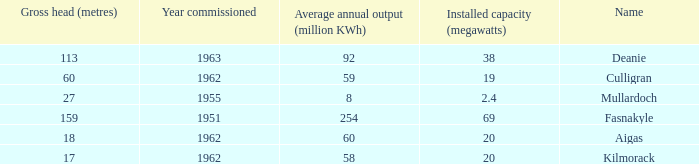What is the Year Commissioned of the power stationo with a Gross head of less than 18? 1962.0. 